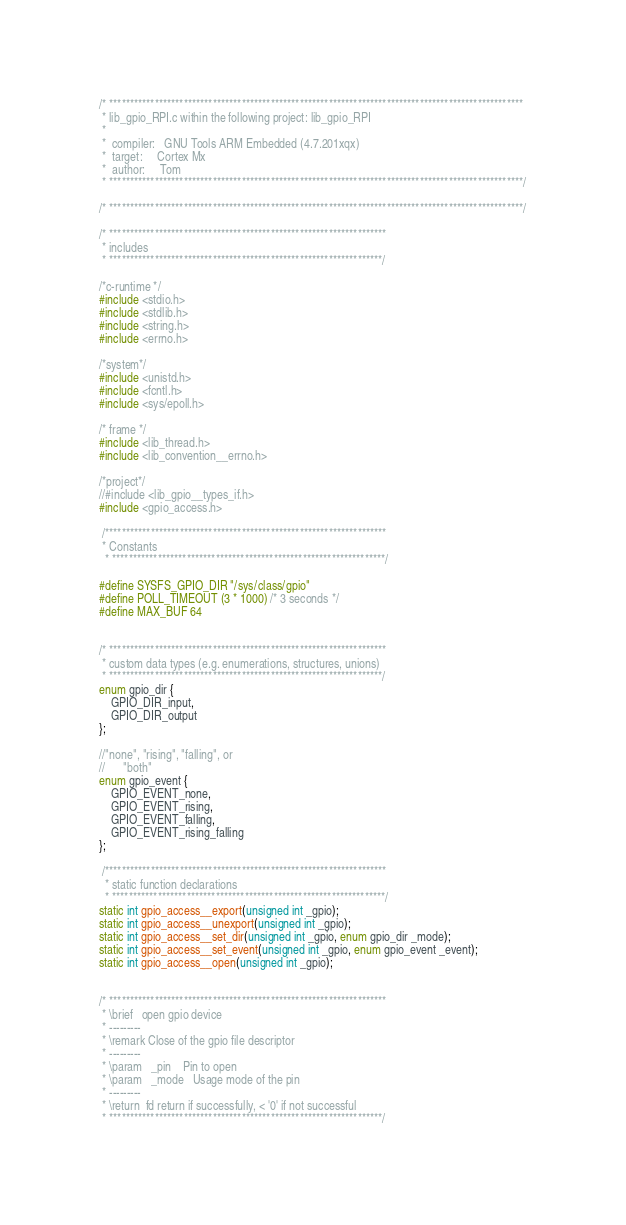<code> <loc_0><loc_0><loc_500><loc_500><_C_>/* ****************************************************************************************************
 * lib_gpio_RPI.c within the following project: lib_gpio_RPI
 *
 *  compiler:   GNU Tools ARM Embedded (4.7.201xqx)
 *  target:     Cortex Mx
 *  author:		Tom
 * ****************************************************************************************************/

/* ****************************************************************************************************/

/* *******************************************************************
 * includes
 * ******************************************************************/

/*c-runtime */
#include <stdio.h>
#include <stdlib.h>
#include <string.h>
#include <errno.h>

/*system*/
#include <unistd.h>
#include <fcntl.h>
#include <sys/epoll.h>

/* frame */
#include <lib_thread.h>
#include <lib_convention__errno.h>

/*project*/
//#include <lib_gpio__types_if.h>
#include <gpio_access.h>

 /********************************************************************
 * Constants
  * ******************************************************************/

#define SYSFS_GPIO_DIR "/sys/class/gpio"
#define POLL_TIMEOUT (3 * 1000) /* 3 seconds */
#define MAX_BUF 64


/* *******************************************************************
 * custom data types (e.g. enumerations, structures, unions)
 * ******************************************************************/
enum gpio_dir {
	GPIO_DIR_input,
	GPIO_DIR_output
};

//"none", "rising", "falling", or
//		"both"
enum gpio_event {
	GPIO_EVENT_none,
	GPIO_EVENT_rising,
	GPIO_EVENT_falling,
	GPIO_EVENT_rising_falling
};

 /********************************************************************
  * static function declarations
  * ******************************************************************/
static int gpio_access__export(unsigned int _gpio);
static int gpio_access__unexport(unsigned int _gpio);
static int gpio_access__set_dir(unsigned int _gpio, enum gpio_dir _mode);
static int gpio_access__set_event(unsigned int _gpio, enum gpio_event _event);
static int gpio_access__open(unsigned int _gpio);


/* *******************************************************************
 * \brief	open gpio device
 * ---------
 * \remark Close of the gpio file descriptor
 * ---------
 * \param	_pin	Pin to open
 * \param   _mode 	Usage mode of the pin
 * ---------
 * \return	fd return if successfully, < '0' if not successful
 * ******************************************************************/</code> 